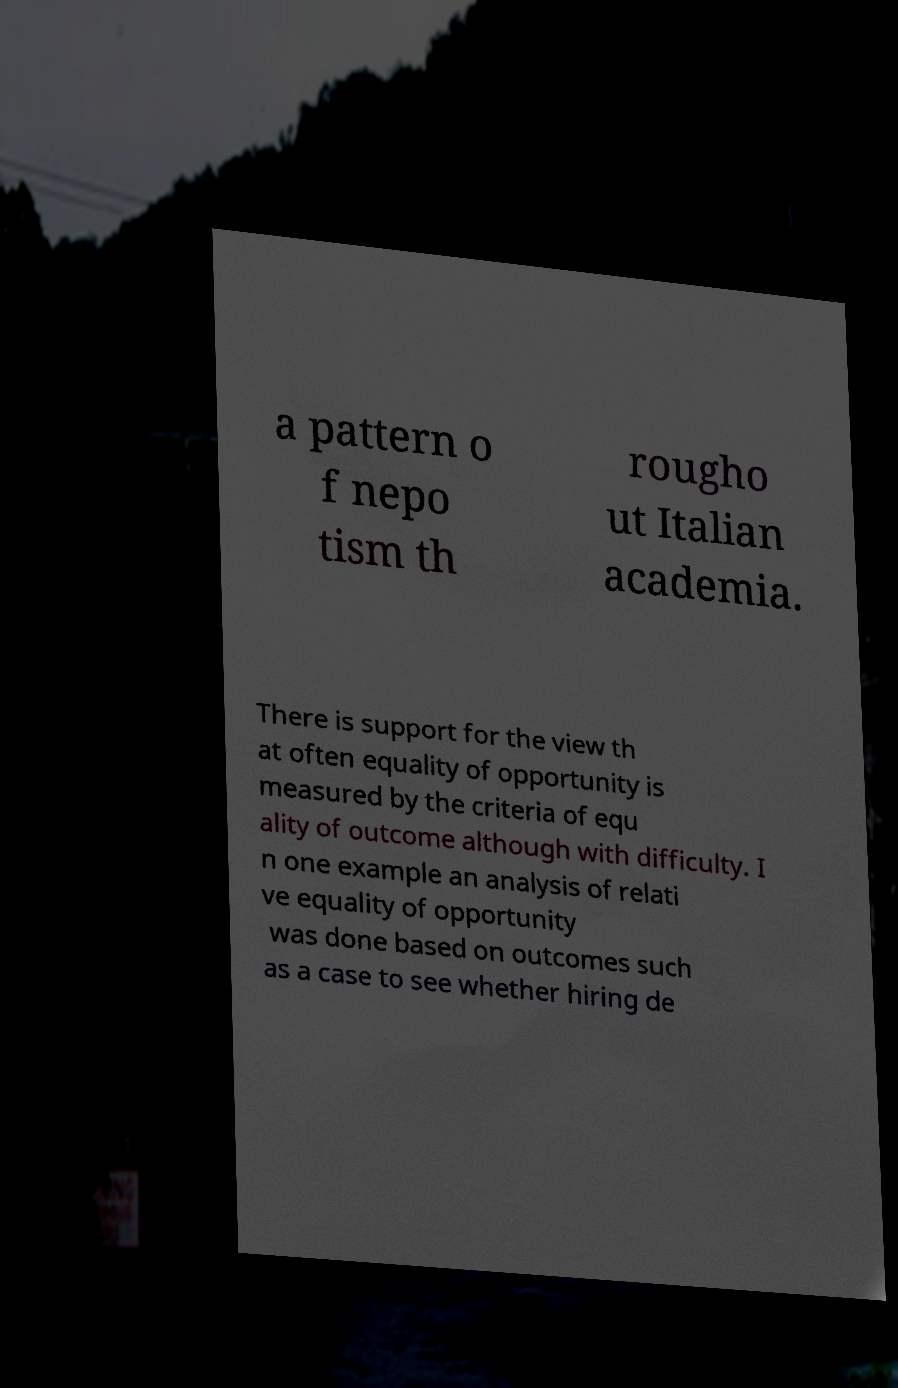Can you accurately transcribe the text from the provided image for me? a pattern o f nepo tism th rougho ut Italian academia. There is support for the view th at often equality of opportunity is measured by the criteria of equ ality of outcome although with difficulty. I n one example an analysis of relati ve equality of opportunity was done based on outcomes such as a case to see whether hiring de 